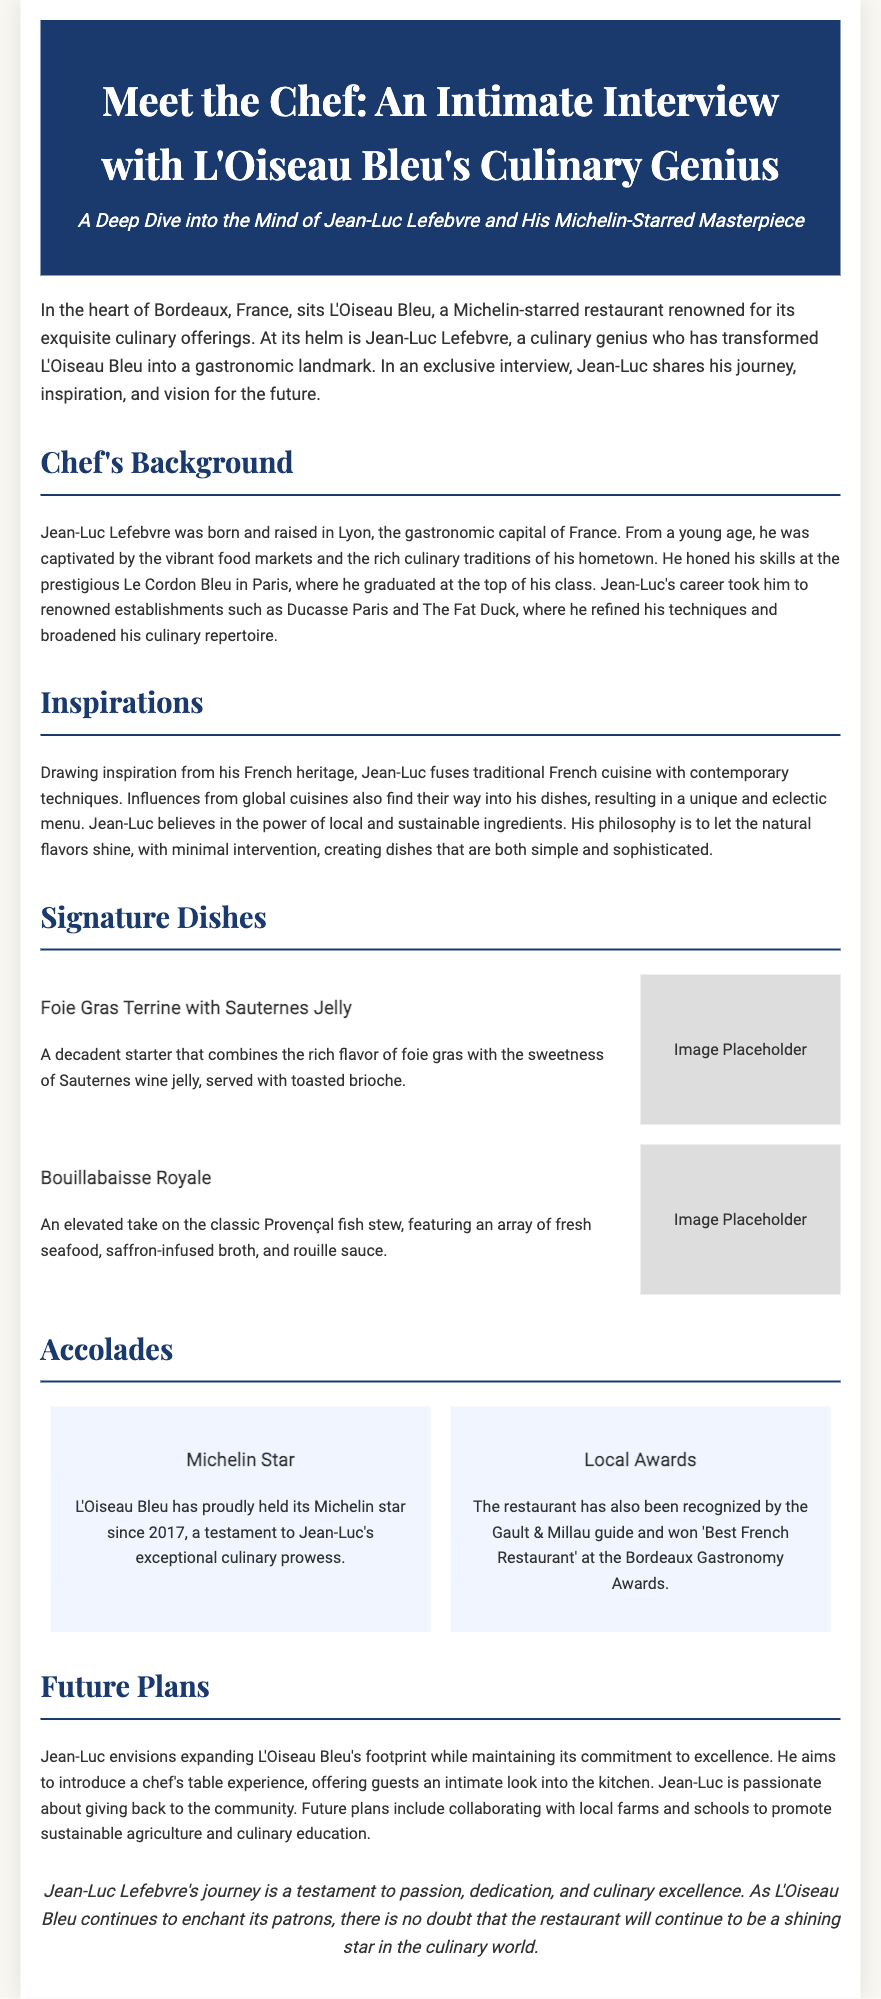what is the name of the chef featured in the interview? The document specifically mentions Jean-Luc Lefebvre as the culinary genius featured in the interview.
Answer: Jean-Luc Lefebvre where is L'Oiseau Bleu located? The document states that L'Oiseau Bleu is situated in Bordeaux, France.
Answer: Bordeaux what prestigious culinary school did Jean-Luc attend? The document indicates that Jean-Luc graduated from Le Cordon Bleu in Paris, which is known for its culinary training.
Answer: Le Cordon Bleu which dish combines foie gras with Sauternes jelly? The document describes the "Foie Gras Terrine with Sauternes Jelly" as one of Jean-Luc's signature dishes.
Answer: Foie Gras Terrine with Sauternes Jelly how long has L'Oiseau Bleu held its Michelin star? According to the document, L'Oiseau Bleu has held its Michelin star since 2017.
Answer: Since 2017 what is one future plan Jean-Luc has for L'Oiseau Bleu? The document mentions Jean-Luc's plan to introduce a chef's table experience, providing an intimate look into the kitchen.
Answer: Chef's table experience what major award did L'Oiseau Bleu win at the Bordeaux Gastronomy Awards? The document states that the restaurant won 'Best French Restaurant' at the Bordeaux Gastronomy Awards.
Answer: Best French Restaurant why does Jean-Luc emphasize local and sustainable ingredients? The document explains that Jean-Luc believes in the power of local and sustainable ingredients to let natural flavors shine in his dishes.
Answer: Natural flavors shine how does Jean-Luc Lefebvre's background influence his cooking? The document highlights that Jean-Luc draws inspiration from his French heritage and fuses traditional cuisine with contemporary techniques.
Answer: French heritage and contemporary techniques 